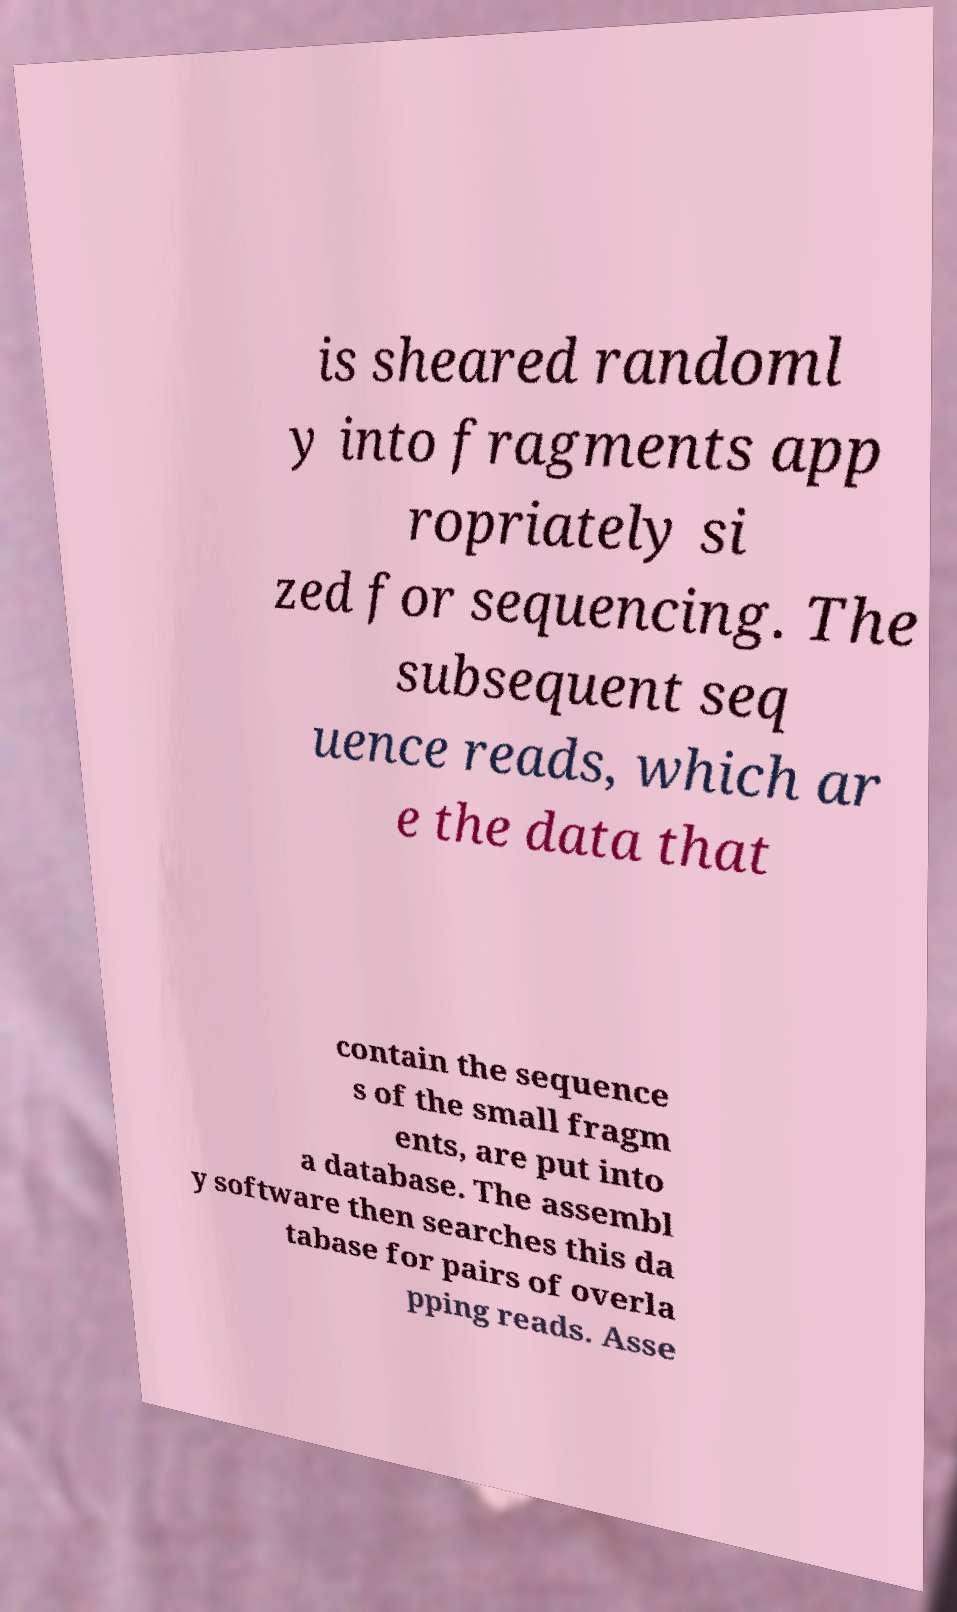Could you extract and type out the text from this image? is sheared randoml y into fragments app ropriately si zed for sequencing. The subsequent seq uence reads, which ar e the data that contain the sequence s of the small fragm ents, are put into a database. The assembl y software then searches this da tabase for pairs of overla pping reads. Asse 